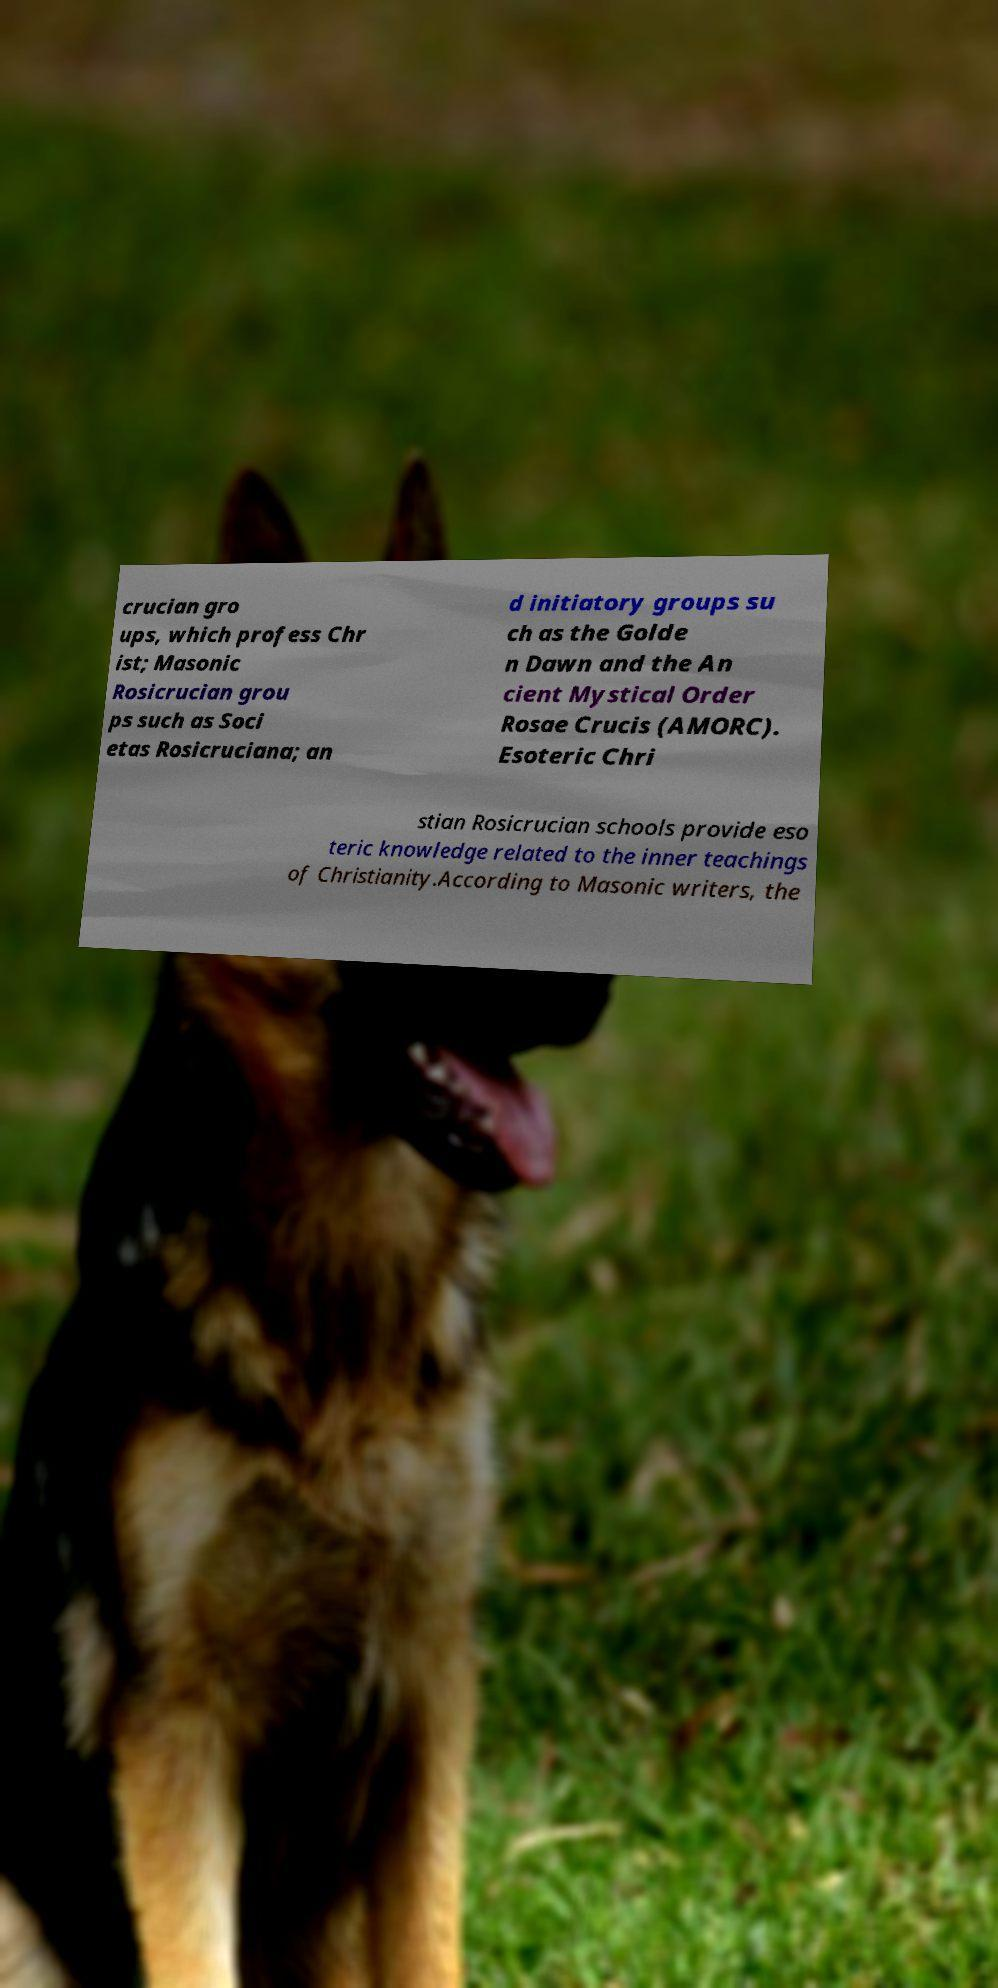Can you accurately transcribe the text from the provided image for me? crucian gro ups, which profess Chr ist; Masonic Rosicrucian grou ps such as Soci etas Rosicruciana; an d initiatory groups su ch as the Golde n Dawn and the An cient Mystical Order Rosae Crucis (AMORC). Esoteric Chri stian Rosicrucian schools provide eso teric knowledge related to the inner teachings of Christianity.According to Masonic writers, the 